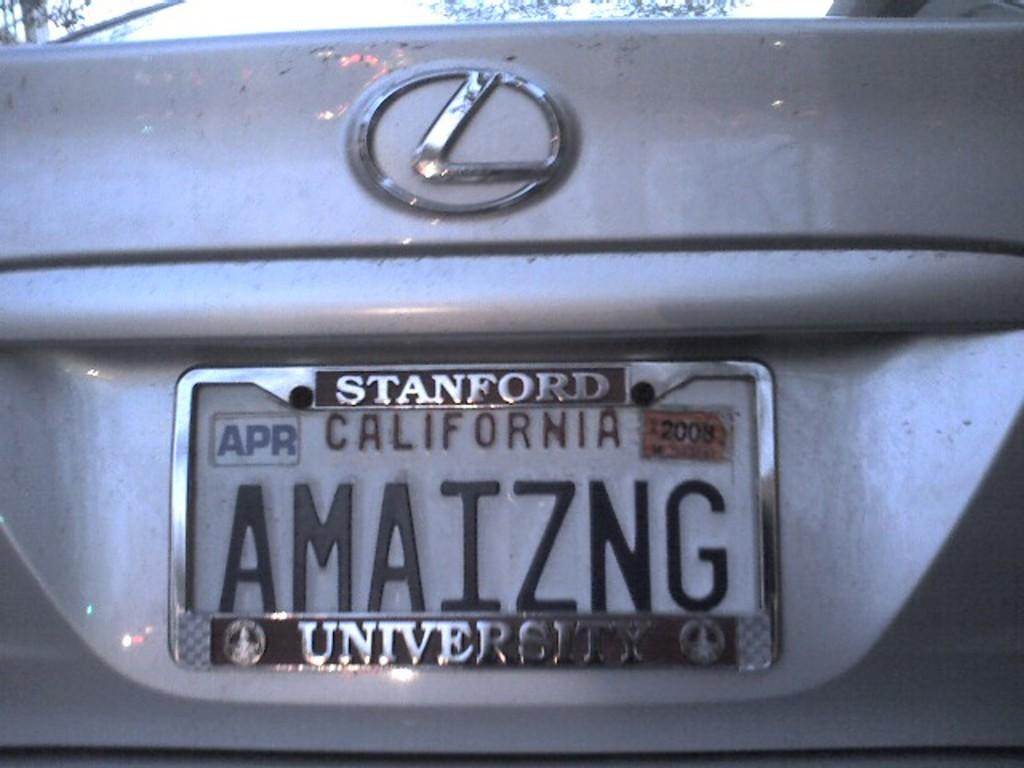What is the main subject of the image? The main subject of the image is the backside part of a car. What type of jam is being spread on the brother's hearing aid in the image? There is no jam, hearing aid, or brother present in the image; it only shows the backside part of a car. 